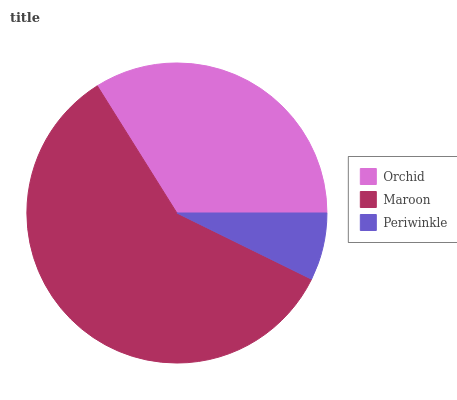Is Periwinkle the minimum?
Answer yes or no. Yes. Is Maroon the maximum?
Answer yes or no. Yes. Is Maroon the minimum?
Answer yes or no. No. Is Periwinkle the maximum?
Answer yes or no. No. Is Maroon greater than Periwinkle?
Answer yes or no. Yes. Is Periwinkle less than Maroon?
Answer yes or no. Yes. Is Periwinkle greater than Maroon?
Answer yes or no. No. Is Maroon less than Periwinkle?
Answer yes or no. No. Is Orchid the high median?
Answer yes or no. Yes. Is Orchid the low median?
Answer yes or no. Yes. Is Periwinkle the high median?
Answer yes or no. No. Is Maroon the low median?
Answer yes or no. No. 